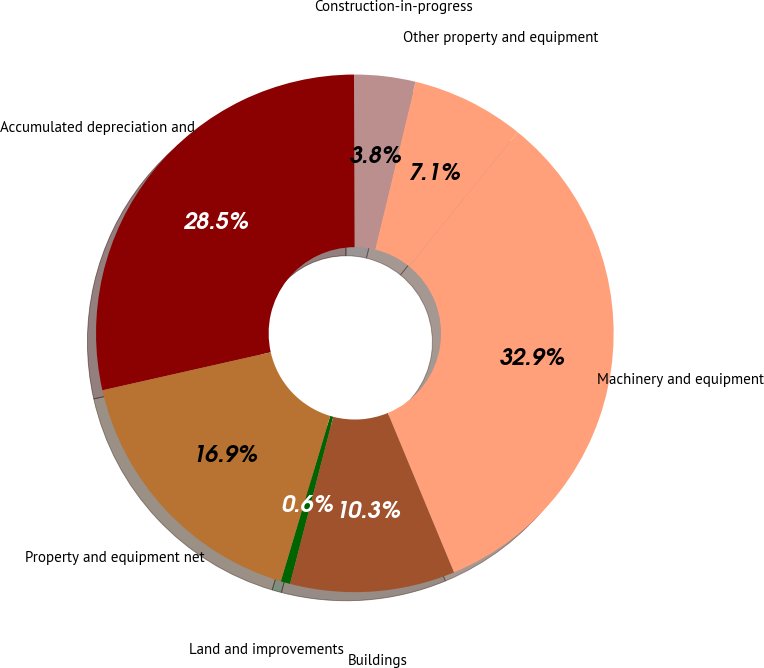Convert chart to OTSL. <chart><loc_0><loc_0><loc_500><loc_500><pie_chart><fcel>Land and improvements<fcel>Buildings<fcel>Machinery and equipment<fcel>Other property and equipment<fcel>Construction-in-progress<fcel>Accumulated depreciation and<fcel>Property and equipment net<nl><fcel>0.59%<fcel>10.29%<fcel>32.91%<fcel>7.06%<fcel>3.82%<fcel>28.48%<fcel>16.85%<nl></chart> 